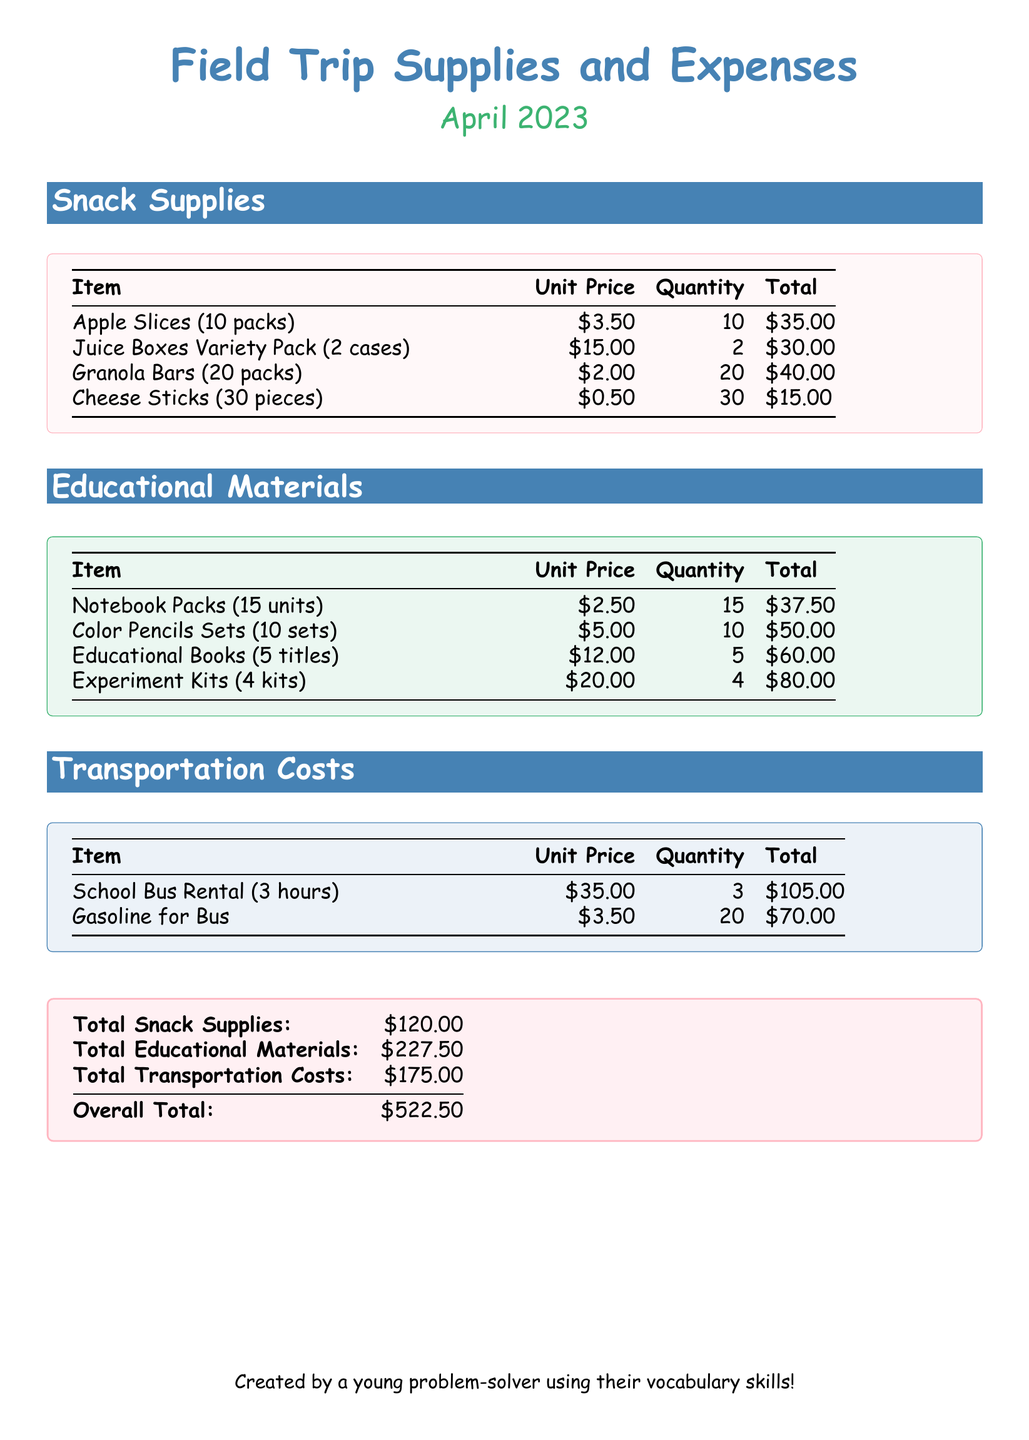What is the total cost of snack supplies? The total cost of snack supplies is listed in the total section of the document, which adds all snack supply totals together.
Answer: $120.00 How many packs of apple slices were purchased? The document lists the quantity of apple slices under the Snack Supplies section.
Answer: 10 What is the unit price of juice boxes? The unit price of juice boxes can be found in the Snack Supplies section where it's specifically mentioned.
Answer: $15.00 How many educational books were bought? The quantity of educational books is provided in the Educational Materials section of the document.
Answer: 5 What is the total transportation cost? The document sums the transportation costs and presents it in the total section.
Answer: $175.00 What is the combined total of snack supplies and educational materials? To find this, you would add the total of snack supplies and educational materials together as shown in the total section.
Answer: $347.50 What is the unit price of granola bars? The unit price for granola bars is specified in the Snack Supplies section of the document.
Answer: $2.00 How many hours was the school bus rented for? The appropriate section shows the quantity of hours for which the school bus was rented.
Answer: 3 What is the overall total cost from all sections? The overall total is provided clearly in the total section of the document after summing up all costs.
Answer: $522.50 